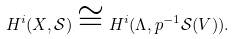<formula> <loc_0><loc_0><loc_500><loc_500>H ^ { i } ( X , \mathcal { S } ) \cong H ^ { i } ( \Lambda , p ^ { - 1 } \mathcal { S } ( V ) ) .</formula> 